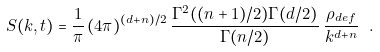<formula> <loc_0><loc_0><loc_500><loc_500>S ( { k } , t ) = \frac { 1 } { \pi } \, ( 4 \pi ) ^ { ( d + n ) / 2 } \, \frac { \Gamma ^ { 2 } ( ( n + 1 ) / 2 ) \Gamma ( d / 2 ) } { \Gamma ( n / 2 ) } \, \frac { \rho _ { d e f } } { k ^ { d + n } } \ .</formula> 